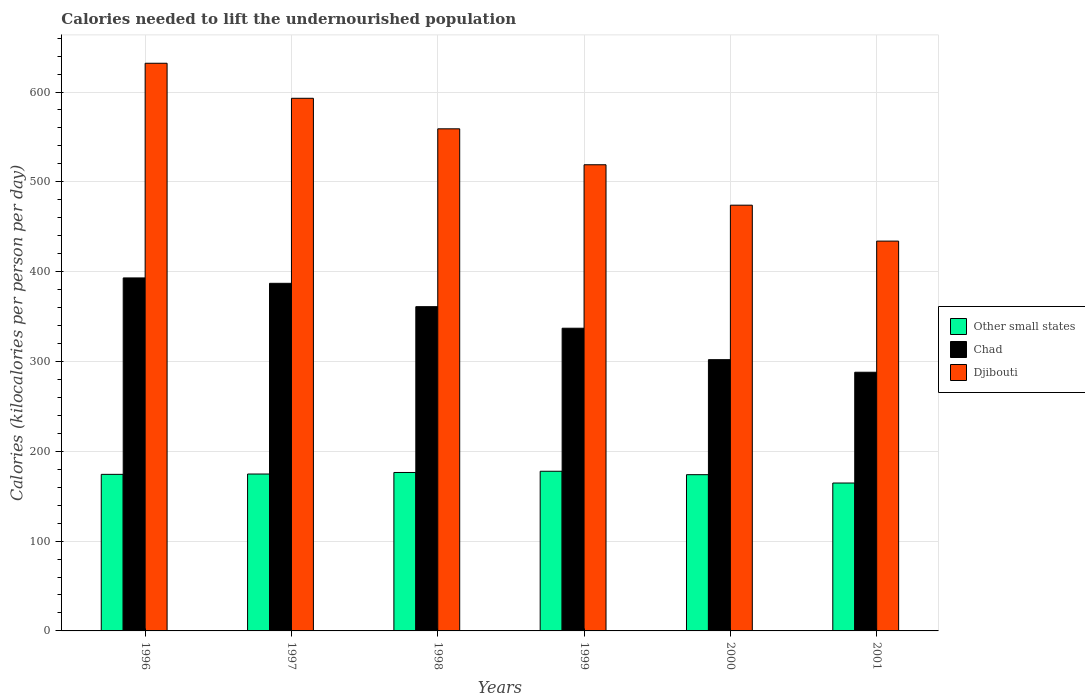Are the number of bars per tick equal to the number of legend labels?
Give a very brief answer. Yes. How many bars are there on the 6th tick from the right?
Provide a short and direct response. 3. What is the label of the 5th group of bars from the left?
Your response must be concise. 2000. What is the total calories needed to lift the undernourished population in Chad in 1999?
Offer a very short reply. 337. Across all years, what is the maximum total calories needed to lift the undernourished population in Other small states?
Your answer should be very brief. 177.76. Across all years, what is the minimum total calories needed to lift the undernourished population in Other small states?
Make the answer very short. 164.66. In which year was the total calories needed to lift the undernourished population in Chad minimum?
Give a very brief answer. 2001. What is the total total calories needed to lift the undernourished population in Djibouti in the graph?
Give a very brief answer. 3211. What is the difference between the total calories needed to lift the undernourished population in Chad in 1999 and that in 2001?
Provide a succinct answer. 49. What is the difference between the total calories needed to lift the undernourished population in Other small states in 2000 and the total calories needed to lift the undernourished population in Djibouti in 1999?
Offer a very short reply. -345.04. What is the average total calories needed to lift the undernourished population in Chad per year?
Make the answer very short. 344.67. In the year 2001, what is the difference between the total calories needed to lift the undernourished population in Chad and total calories needed to lift the undernourished population in Djibouti?
Your response must be concise. -146. In how many years, is the total calories needed to lift the undernourished population in Chad greater than 520 kilocalories?
Provide a short and direct response. 0. What is the ratio of the total calories needed to lift the undernourished population in Djibouti in 1996 to that in 1997?
Your response must be concise. 1.07. Is the total calories needed to lift the undernourished population in Chad in 1999 less than that in 2000?
Give a very brief answer. No. What is the difference between the highest and the second highest total calories needed to lift the undernourished population in Chad?
Give a very brief answer. 6. What is the difference between the highest and the lowest total calories needed to lift the undernourished population in Djibouti?
Offer a very short reply. 198. In how many years, is the total calories needed to lift the undernourished population in Chad greater than the average total calories needed to lift the undernourished population in Chad taken over all years?
Ensure brevity in your answer.  3. Is the sum of the total calories needed to lift the undernourished population in Djibouti in 1998 and 2000 greater than the maximum total calories needed to lift the undernourished population in Chad across all years?
Your response must be concise. Yes. What does the 1st bar from the left in 1996 represents?
Provide a short and direct response. Other small states. What does the 1st bar from the right in 2000 represents?
Provide a succinct answer. Djibouti. Are all the bars in the graph horizontal?
Your answer should be compact. No. Are the values on the major ticks of Y-axis written in scientific E-notation?
Your response must be concise. No. Does the graph contain grids?
Your response must be concise. Yes. How are the legend labels stacked?
Ensure brevity in your answer.  Vertical. What is the title of the graph?
Your answer should be compact. Calories needed to lift the undernourished population. Does "Mongolia" appear as one of the legend labels in the graph?
Provide a succinct answer. No. What is the label or title of the X-axis?
Make the answer very short. Years. What is the label or title of the Y-axis?
Offer a very short reply. Calories (kilocalories per person per day). What is the Calories (kilocalories per person per day) of Other small states in 1996?
Keep it short and to the point. 174.31. What is the Calories (kilocalories per person per day) in Chad in 1996?
Offer a very short reply. 393. What is the Calories (kilocalories per person per day) in Djibouti in 1996?
Give a very brief answer. 632. What is the Calories (kilocalories per person per day) of Other small states in 1997?
Offer a very short reply. 174.68. What is the Calories (kilocalories per person per day) of Chad in 1997?
Your answer should be compact. 387. What is the Calories (kilocalories per person per day) of Djibouti in 1997?
Offer a very short reply. 593. What is the Calories (kilocalories per person per day) in Other small states in 1998?
Offer a terse response. 176.41. What is the Calories (kilocalories per person per day) of Chad in 1998?
Provide a short and direct response. 361. What is the Calories (kilocalories per person per day) in Djibouti in 1998?
Offer a terse response. 559. What is the Calories (kilocalories per person per day) in Other small states in 1999?
Provide a short and direct response. 177.76. What is the Calories (kilocalories per person per day) of Chad in 1999?
Keep it short and to the point. 337. What is the Calories (kilocalories per person per day) in Djibouti in 1999?
Keep it short and to the point. 519. What is the Calories (kilocalories per person per day) in Other small states in 2000?
Ensure brevity in your answer.  173.96. What is the Calories (kilocalories per person per day) in Chad in 2000?
Keep it short and to the point. 302. What is the Calories (kilocalories per person per day) of Djibouti in 2000?
Provide a succinct answer. 474. What is the Calories (kilocalories per person per day) of Other small states in 2001?
Keep it short and to the point. 164.66. What is the Calories (kilocalories per person per day) of Chad in 2001?
Provide a short and direct response. 288. What is the Calories (kilocalories per person per day) of Djibouti in 2001?
Offer a very short reply. 434. Across all years, what is the maximum Calories (kilocalories per person per day) in Other small states?
Keep it short and to the point. 177.76. Across all years, what is the maximum Calories (kilocalories per person per day) in Chad?
Make the answer very short. 393. Across all years, what is the maximum Calories (kilocalories per person per day) of Djibouti?
Keep it short and to the point. 632. Across all years, what is the minimum Calories (kilocalories per person per day) in Other small states?
Give a very brief answer. 164.66. Across all years, what is the minimum Calories (kilocalories per person per day) in Chad?
Give a very brief answer. 288. Across all years, what is the minimum Calories (kilocalories per person per day) of Djibouti?
Keep it short and to the point. 434. What is the total Calories (kilocalories per person per day) in Other small states in the graph?
Offer a terse response. 1041.77. What is the total Calories (kilocalories per person per day) of Chad in the graph?
Your answer should be compact. 2068. What is the total Calories (kilocalories per person per day) in Djibouti in the graph?
Make the answer very short. 3211. What is the difference between the Calories (kilocalories per person per day) of Other small states in 1996 and that in 1997?
Offer a very short reply. -0.37. What is the difference between the Calories (kilocalories per person per day) in Chad in 1996 and that in 1997?
Offer a very short reply. 6. What is the difference between the Calories (kilocalories per person per day) in Djibouti in 1996 and that in 1997?
Your answer should be very brief. 39. What is the difference between the Calories (kilocalories per person per day) in Other small states in 1996 and that in 1998?
Give a very brief answer. -2.09. What is the difference between the Calories (kilocalories per person per day) of Chad in 1996 and that in 1998?
Offer a terse response. 32. What is the difference between the Calories (kilocalories per person per day) of Djibouti in 1996 and that in 1998?
Provide a short and direct response. 73. What is the difference between the Calories (kilocalories per person per day) in Other small states in 1996 and that in 1999?
Keep it short and to the point. -3.45. What is the difference between the Calories (kilocalories per person per day) of Chad in 1996 and that in 1999?
Your answer should be very brief. 56. What is the difference between the Calories (kilocalories per person per day) of Djibouti in 1996 and that in 1999?
Provide a succinct answer. 113. What is the difference between the Calories (kilocalories per person per day) in Other small states in 1996 and that in 2000?
Make the answer very short. 0.35. What is the difference between the Calories (kilocalories per person per day) in Chad in 1996 and that in 2000?
Your answer should be compact. 91. What is the difference between the Calories (kilocalories per person per day) of Djibouti in 1996 and that in 2000?
Your answer should be compact. 158. What is the difference between the Calories (kilocalories per person per day) of Other small states in 1996 and that in 2001?
Your answer should be compact. 9.65. What is the difference between the Calories (kilocalories per person per day) in Chad in 1996 and that in 2001?
Your answer should be very brief. 105. What is the difference between the Calories (kilocalories per person per day) in Djibouti in 1996 and that in 2001?
Ensure brevity in your answer.  198. What is the difference between the Calories (kilocalories per person per day) in Other small states in 1997 and that in 1998?
Your response must be concise. -1.73. What is the difference between the Calories (kilocalories per person per day) in Other small states in 1997 and that in 1999?
Provide a short and direct response. -3.08. What is the difference between the Calories (kilocalories per person per day) of Chad in 1997 and that in 1999?
Provide a short and direct response. 50. What is the difference between the Calories (kilocalories per person per day) in Djibouti in 1997 and that in 1999?
Your answer should be compact. 74. What is the difference between the Calories (kilocalories per person per day) in Other small states in 1997 and that in 2000?
Make the answer very short. 0.72. What is the difference between the Calories (kilocalories per person per day) of Chad in 1997 and that in 2000?
Provide a short and direct response. 85. What is the difference between the Calories (kilocalories per person per day) in Djibouti in 1997 and that in 2000?
Offer a very short reply. 119. What is the difference between the Calories (kilocalories per person per day) of Other small states in 1997 and that in 2001?
Ensure brevity in your answer.  10.02. What is the difference between the Calories (kilocalories per person per day) of Djibouti in 1997 and that in 2001?
Make the answer very short. 159. What is the difference between the Calories (kilocalories per person per day) of Other small states in 1998 and that in 1999?
Your answer should be compact. -1.35. What is the difference between the Calories (kilocalories per person per day) of Other small states in 1998 and that in 2000?
Your answer should be very brief. 2.45. What is the difference between the Calories (kilocalories per person per day) in Chad in 1998 and that in 2000?
Provide a short and direct response. 59. What is the difference between the Calories (kilocalories per person per day) in Djibouti in 1998 and that in 2000?
Provide a short and direct response. 85. What is the difference between the Calories (kilocalories per person per day) of Other small states in 1998 and that in 2001?
Ensure brevity in your answer.  11.75. What is the difference between the Calories (kilocalories per person per day) in Chad in 1998 and that in 2001?
Provide a short and direct response. 73. What is the difference between the Calories (kilocalories per person per day) in Djibouti in 1998 and that in 2001?
Your answer should be very brief. 125. What is the difference between the Calories (kilocalories per person per day) in Other small states in 1999 and that in 2000?
Make the answer very short. 3.8. What is the difference between the Calories (kilocalories per person per day) of Chad in 1999 and that in 2000?
Provide a short and direct response. 35. What is the difference between the Calories (kilocalories per person per day) of Other small states in 1999 and that in 2001?
Provide a succinct answer. 13.1. What is the difference between the Calories (kilocalories per person per day) in Chad in 1999 and that in 2001?
Your answer should be very brief. 49. What is the difference between the Calories (kilocalories per person per day) of Djibouti in 1999 and that in 2001?
Offer a very short reply. 85. What is the difference between the Calories (kilocalories per person per day) of Other small states in 2000 and that in 2001?
Keep it short and to the point. 9.3. What is the difference between the Calories (kilocalories per person per day) of Other small states in 1996 and the Calories (kilocalories per person per day) of Chad in 1997?
Keep it short and to the point. -212.69. What is the difference between the Calories (kilocalories per person per day) of Other small states in 1996 and the Calories (kilocalories per person per day) of Djibouti in 1997?
Your answer should be very brief. -418.69. What is the difference between the Calories (kilocalories per person per day) in Chad in 1996 and the Calories (kilocalories per person per day) in Djibouti in 1997?
Offer a very short reply. -200. What is the difference between the Calories (kilocalories per person per day) of Other small states in 1996 and the Calories (kilocalories per person per day) of Chad in 1998?
Your answer should be very brief. -186.69. What is the difference between the Calories (kilocalories per person per day) in Other small states in 1996 and the Calories (kilocalories per person per day) in Djibouti in 1998?
Ensure brevity in your answer.  -384.69. What is the difference between the Calories (kilocalories per person per day) in Chad in 1996 and the Calories (kilocalories per person per day) in Djibouti in 1998?
Offer a very short reply. -166. What is the difference between the Calories (kilocalories per person per day) of Other small states in 1996 and the Calories (kilocalories per person per day) of Chad in 1999?
Offer a terse response. -162.69. What is the difference between the Calories (kilocalories per person per day) in Other small states in 1996 and the Calories (kilocalories per person per day) in Djibouti in 1999?
Offer a terse response. -344.69. What is the difference between the Calories (kilocalories per person per day) in Chad in 1996 and the Calories (kilocalories per person per day) in Djibouti in 1999?
Give a very brief answer. -126. What is the difference between the Calories (kilocalories per person per day) in Other small states in 1996 and the Calories (kilocalories per person per day) in Chad in 2000?
Give a very brief answer. -127.69. What is the difference between the Calories (kilocalories per person per day) in Other small states in 1996 and the Calories (kilocalories per person per day) in Djibouti in 2000?
Make the answer very short. -299.69. What is the difference between the Calories (kilocalories per person per day) of Chad in 1996 and the Calories (kilocalories per person per day) of Djibouti in 2000?
Your answer should be compact. -81. What is the difference between the Calories (kilocalories per person per day) of Other small states in 1996 and the Calories (kilocalories per person per day) of Chad in 2001?
Your answer should be very brief. -113.69. What is the difference between the Calories (kilocalories per person per day) in Other small states in 1996 and the Calories (kilocalories per person per day) in Djibouti in 2001?
Make the answer very short. -259.69. What is the difference between the Calories (kilocalories per person per day) in Chad in 1996 and the Calories (kilocalories per person per day) in Djibouti in 2001?
Provide a succinct answer. -41. What is the difference between the Calories (kilocalories per person per day) of Other small states in 1997 and the Calories (kilocalories per person per day) of Chad in 1998?
Keep it short and to the point. -186.32. What is the difference between the Calories (kilocalories per person per day) in Other small states in 1997 and the Calories (kilocalories per person per day) in Djibouti in 1998?
Keep it short and to the point. -384.32. What is the difference between the Calories (kilocalories per person per day) of Chad in 1997 and the Calories (kilocalories per person per day) of Djibouti in 1998?
Your answer should be compact. -172. What is the difference between the Calories (kilocalories per person per day) in Other small states in 1997 and the Calories (kilocalories per person per day) in Chad in 1999?
Give a very brief answer. -162.32. What is the difference between the Calories (kilocalories per person per day) in Other small states in 1997 and the Calories (kilocalories per person per day) in Djibouti in 1999?
Your answer should be compact. -344.32. What is the difference between the Calories (kilocalories per person per day) of Chad in 1997 and the Calories (kilocalories per person per day) of Djibouti in 1999?
Keep it short and to the point. -132. What is the difference between the Calories (kilocalories per person per day) of Other small states in 1997 and the Calories (kilocalories per person per day) of Chad in 2000?
Your response must be concise. -127.32. What is the difference between the Calories (kilocalories per person per day) in Other small states in 1997 and the Calories (kilocalories per person per day) in Djibouti in 2000?
Keep it short and to the point. -299.32. What is the difference between the Calories (kilocalories per person per day) of Chad in 1997 and the Calories (kilocalories per person per day) of Djibouti in 2000?
Keep it short and to the point. -87. What is the difference between the Calories (kilocalories per person per day) in Other small states in 1997 and the Calories (kilocalories per person per day) in Chad in 2001?
Offer a very short reply. -113.32. What is the difference between the Calories (kilocalories per person per day) in Other small states in 1997 and the Calories (kilocalories per person per day) in Djibouti in 2001?
Give a very brief answer. -259.32. What is the difference between the Calories (kilocalories per person per day) of Chad in 1997 and the Calories (kilocalories per person per day) of Djibouti in 2001?
Ensure brevity in your answer.  -47. What is the difference between the Calories (kilocalories per person per day) in Other small states in 1998 and the Calories (kilocalories per person per day) in Chad in 1999?
Keep it short and to the point. -160.59. What is the difference between the Calories (kilocalories per person per day) of Other small states in 1998 and the Calories (kilocalories per person per day) of Djibouti in 1999?
Ensure brevity in your answer.  -342.59. What is the difference between the Calories (kilocalories per person per day) of Chad in 1998 and the Calories (kilocalories per person per day) of Djibouti in 1999?
Your answer should be compact. -158. What is the difference between the Calories (kilocalories per person per day) in Other small states in 1998 and the Calories (kilocalories per person per day) in Chad in 2000?
Your response must be concise. -125.59. What is the difference between the Calories (kilocalories per person per day) in Other small states in 1998 and the Calories (kilocalories per person per day) in Djibouti in 2000?
Give a very brief answer. -297.59. What is the difference between the Calories (kilocalories per person per day) in Chad in 1998 and the Calories (kilocalories per person per day) in Djibouti in 2000?
Offer a terse response. -113. What is the difference between the Calories (kilocalories per person per day) of Other small states in 1998 and the Calories (kilocalories per person per day) of Chad in 2001?
Ensure brevity in your answer.  -111.59. What is the difference between the Calories (kilocalories per person per day) of Other small states in 1998 and the Calories (kilocalories per person per day) of Djibouti in 2001?
Offer a terse response. -257.59. What is the difference between the Calories (kilocalories per person per day) of Chad in 1998 and the Calories (kilocalories per person per day) of Djibouti in 2001?
Your answer should be very brief. -73. What is the difference between the Calories (kilocalories per person per day) in Other small states in 1999 and the Calories (kilocalories per person per day) in Chad in 2000?
Offer a terse response. -124.24. What is the difference between the Calories (kilocalories per person per day) in Other small states in 1999 and the Calories (kilocalories per person per day) in Djibouti in 2000?
Your answer should be very brief. -296.24. What is the difference between the Calories (kilocalories per person per day) in Chad in 1999 and the Calories (kilocalories per person per day) in Djibouti in 2000?
Give a very brief answer. -137. What is the difference between the Calories (kilocalories per person per day) in Other small states in 1999 and the Calories (kilocalories per person per day) in Chad in 2001?
Offer a terse response. -110.24. What is the difference between the Calories (kilocalories per person per day) of Other small states in 1999 and the Calories (kilocalories per person per day) of Djibouti in 2001?
Your answer should be very brief. -256.24. What is the difference between the Calories (kilocalories per person per day) of Chad in 1999 and the Calories (kilocalories per person per day) of Djibouti in 2001?
Offer a very short reply. -97. What is the difference between the Calories (kilocalories per person per day) of Other small states in 2000 and the Calories (kilocalories per person per day) of Chad in 2001?
Keep it short and to the point. -114.04. What is the difference between the Calories (kilocalories per person per day) in Other small states in 2000 and the Calories (kilocalories per person per day) in Djibouti in 2001?
Provide a short and direct response. -260.04. What is the difference between the Calories (kilocalories per person per day) in Chad in 2000 and the Calories (kilocalories per person per day) in Djibouti in 2001?
Give a very brief answer. -132. What is the average Calories (kilocalories per person per day) of Other small states per year?
Provide a succinct answer. 173.63. What is the average Calories (kilocalories per person per day) in Chad per year?
Your answer should be very brief. 344.67. What is the average Calories (kilocalories per person per day) in Djibouti per year?
Your response must be concise. 535.17. In the year 1996, what is the difference between the Calories (kilocalories per person per day) of Other small states and Calories (kilocalories per person per day) of Chad?
Keep it short and to the point. -218.69. In the year 1996, what is the difference between the Calories (kilocalories per person per day) in Other small states and Calories (kilocalories per person per day) in Djibouti?
Keep it short and to the point. -457.69. In the year 1996, what is the difference between the Calories (kilocalories per person per day) in Chad and Calories (kilocalories per person per day) in Djibouti?
Provide a short and direct response. -239. In the year 1997, what is the difference between the Calories (kilocalories per person per day) in Other small states and Calories (kilocalories per person per day) in Chad?
Keep it short and to the point. -212.32. In the year 1997, what is the difference between the Calories (kilocalories per person per day) in Other small states and Calories (kilocalories per person per day) in Djibouti?
Offer a terse response. -418.32. In the year 1997, what is the difference between the Calories (kilocalories per person per day) in Chad and Calories (kilocalories per person per day) in Djibouti?
Your answer should be very brief. -206. In the year 1998, what is the difference between the Calories (kilocalories per person per day) in Other small states and Calories (kilocalories per person per day) in Chad?
Your answer should be compact. -184.59. In the year 1998, what is the difference between the Calories (kilocalories per person per day) in Other small states and Calories (kilocalories per person per day) in Djibouti?
Ensure brevity in your answer.  -382.59. In the year 1998, what is the difference between the Calories (kilocalories per person per day) of Chad and Calories (kilocalories per person per day) of Djibouti?
Ensure brevity in your answer.  -198. In the year 1999, what is the difference between the Calories (kilocalories per person per day) in Other small states and Calories (kilocalories per person per day) in Chad?
Offer a very short reply. -159.24. In the year 1999, what is the difference between the Calories (kilocalories per person per day) of Other small states and Calories (kilocalories per person per day) of Djibouti?
Give a very brief answer. -341.24. In the year 1999, what is the difference between the Calories (kilocalories per person per day) in Chad and Calories (kilocalories per person per day) in Djibouti?
Keep it short and to the point. -182. In the year 2000, what is the difference between the Calories (kilocalories per person per day) of Other small states and Calories (kilocalories per person per day) of Chad?
Your answer should be compact. -128.04. In the year 2000, what is the difference between the Calories (kilocalories per person per day) in Other small states and Calories (kilocalories per person per day) in Djibouti?
Offer a very short reply. -300.04. In the year 2000, what is the difference between the Calories (kilocalories per person per day) of Chad and Calories (kilocalories per person per day) of Djibouti?
Offer a terse response. -172. In the year 2001, what is the difference between the Calories (kilocalories per person per day) in Other small states and Calories (kilocalories per person per day) in Chad?
Keep it short and to the point. -123.34. In the year 2001, what is the difference between the Calories (kilocalories per person per day) in Other small states and Calories (kilocalories per person per day) in Djibouti?
Offer a very short reply. -269.34. In the year 2001, what is the difference between the Calories (kilocalories per person per day) of Chad and Calories (kilocalories per person per day) of Djibouti?
Your answer should be very brief. -146. What is the ratio of the Calories (kilocalories per person per day) in Other small states in 1996 to that in 1997?
Your answer should be compact. 1. What is the ratio of the Calories (kilocalories per person per day) in Chad in 1996 to that in 1997?
Your answer should be compact. 1.02. What is the ratio of the Calories (kilocalories per person per day) of Djibouti in 1996 to that in 1997?
Provide a succinct answer. 1.07. What is the ratio of the Calories (kilocalories per person per day) in Chad in 1996 to that in 1998?
Your response must be concise. 1.09. What is the ratio of the Calories (kilocalories per person per day) of Djibouti in 1996 to that in 1998?
Offer a terse response. 1.13. What is the ratio of the Calories (kilocalories per person per day) in Other small states in 1996 to that in 1999?
Make the answer very short. 0.98. What is the ratio of the Calories (kilocalories per person per day) in Chad in 1996 to that in 1999?
Keep it short and to the point. 1.17. What is the ratio of the Calories (kilocalories per person per day) of Djibouti in 1996 to that in 1999?
Offer a very short reply. 1.22. What is the ratio of the Calories (kilocalories per person per day) of Chad in 1996 to that in 2000?
Provide a succinct answer. 1.3. What is the ratio of the Calories (kilocalories per person per day) of Djibouti in 1996 to that in 2000?
Ensure brevity in your answer.  1.33. What is the ratio of the Calories (kilocalories per person per day) in Other small states in 1996 to that in 2001?
Make the answer very short. 1.06. What is the ratio of the Calories (kilocalories per person per day) of Chad in 1996 to that in 2001?
Ensure brevity in your answer.  1.36. What is the ratio of the Calories (kilocalories per person per day) of Djibouti in 1996 to that in 2001?
Your answer should be very brief. 1.46. What is the ratio of the Calories (kilocalories per person per day) in Other small states in 1997 to that in 1998?
Your response must be concise. 0.99. What is the ratio of the Calories (kilocalories per person per day) of Chad in 1997 to that in 1998?
Ensure brevity in your answer.  1.07. What is the ratio of the Calories (kilocalories per person per day) in Djibouti in 1997 to that in 1998?
Your answer should be very brief. 1.06. What is the ratio of the Calories (kilocalories per person per day) in Other small states in 1997 to that in 1999?
Provide a short and direct response. 0.98. What is the ratio of the Calories (kilocalories per person per day) in Chad in 1997 to that in 1999?
Your answer should be compact. 1.15. What is the ratio of the Calories (kilocalories per person per day) of Djibouti in 1997 to that in 1999?
Ensure brevity in your answer.  1.14. What is the ratio of the Calories (kilocalories per person per day) of Other small states in 1997 to that in 2000?
Your response must be concise. 1. What is the ratio of the Calories (kilocalories per person per day) of Chad in 1997 to that in 2000?
Provide a succinct answer. 1.28. What is the ratio of the Calories (kilocalories per person per day) of Djibouti in 1997 to that in 2000?
Make the answer very short. 1.25. What is the ratio of the Calories (kilocalories per person per day) of Other small states in 1997 to that in 2001?
Give a very brief answer. 1.06. What is the ratio of the Calories (kilocalories per person per day) in Chad in 1997 to that in 2001?
Your answer should be very brief. 1.34. What is the ratio of the Calories (kilocalories per person per day) of Djibouti in 1997 to that in 2001?
Offer a terse response. 1.37. What is the ratio of the Calories (kilocalories per person per day) of Other small states in 1998 to that in 1999?
Make the answer very short. 0.99. What is the ratio of the Calories (kilocalories per person per day) of Chad in 1998 to that in 1999?
Provide a succinct answer. 1.07. What is the ratio of the Calories (kilocalories per person per day) of Djibouti in 1998 to that in 1999?
Provide a short and direct response. 1.08. What is the ratio of the Calories (kilocalories per person per day) of Other small states in 1998 to that in 2000?
Ensure brevity in your answer.  1.01. What is the ratio of the Calories (kilocalories per person per day) of Chad in 1998 to that in 2000?
Make the answer very short. 1.2. What is the ratio of the Calories (kilocalories per person per day) of Djibouti in 1998 to that in 2000?
Provide a short and direct response. 1.18. What is the ratio of the Calories (kilocalories per person per day) in Other small states in 1998 to that in 2001?
Your answer should be compact. 1.07. What is the ratio of the Calories (kilocalories per person per day) of Chad in 1998 to that in 2001?
Provide a short and direct response. 1.25. What is the ratio of the Calories (kilocalories per person per day) of Djibouti in 1998 to that in 2001?
Provide a short and direct response. 1.29. What is the ratio of the Calories (kilocalories per person per day) in Other small states in 1999 to that in 2000?
Keep it short and to the point. 1.02. What is the ratio of the Calories (kilocalories per person per day) in Chad in 1999 to that in 2000?
Keep it short and to the point. 1.12. What is the ratio of the Calories (kilocalories per person per day) of Djibouti in 1999 to that in 2000?
Give a very brief answer. 1.09. What is the ratio of the Calories (kilocalories per person per day) in Other small states in 1999 to that in 2001?
Ensure brevity in your answer.  1.08. What is the ratio of the Calories (kilocalories per person per day) of Chad in 1999 to that in 2001?
Your response must be concise. 1.17. What is the ratio of the Calories (kilocalories per person per day) in Djibouti in 1999 to that in 2001?
Make the answer very short. 1.2. What is the ratio of the Calories (kilocalories per person per day) of Other small states in 2000 to that in 2001?
Your response must be concise. 1.06. What is the ratio of the Calories (kilocalories per person per day) in Chad in 2000 to that in 2001?
Keep it short and to the point. 1.05. What is the ratio of the Calories (kilocalories per person per day) of Djibouti in 2000 to that in 2001?
Offer a very short reply. 1.09. What is the difference between the highest and the second highest Calories (kilocalories per person per day) of Other small states?
Your response must be concise. 1.35. What is the difference between the highest and the second highest Calories (kilocalories per person per day) of Djibouti?
Give a very brief answer. 39. What is the difference between the highest and the lowest Calories (kilocalories per person per day) of Other small states?
Your answer should be compact. 13.1. What is the difference between the highest and the lowest Calories (kilocalories per person per day) in Chad?
Provide a succinct answer. 105. What is the difference between the highest and the lowest Calories (kilocalories per person per day) of Djibouti?
Offer a terse response. 198. 